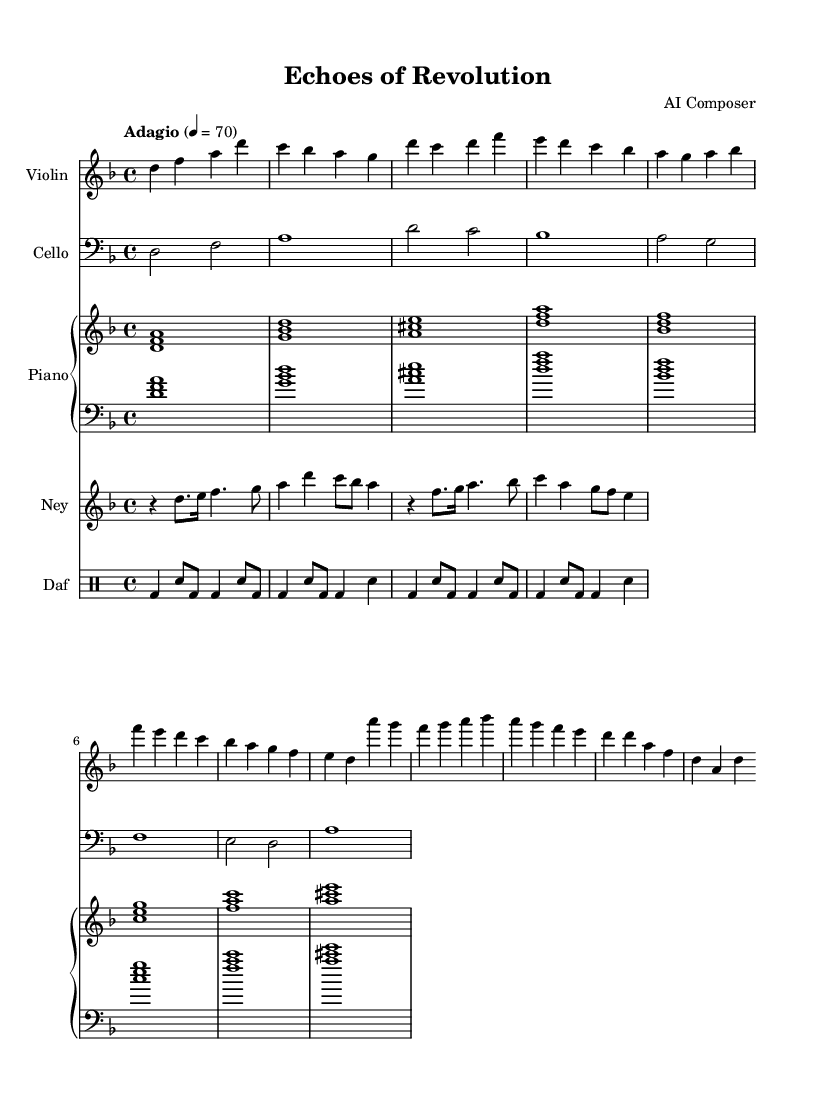What is the key signature of this music? The music is in D minor, which has one flat (B♭). The key signature can be found at the beginning of the staff, where the flat symbol is indicated.
Answer: D minor What is the time signature of this piece? The time signature is 4/4, which indicates that there are four beats in each measure and the quarter note gets one beat. This can be seen at the beginning of the score, right after the key signature.
Answer: 4/4 What is the tempo marking for this music? The tempo marking shown is "Adagio," which generally means a slow tempo. The beats per minute indicated is 70, providing a specific speed for the performance. This information is displayed at the beginning of the score alongside the tempo indication.
Answer: Adagio How many measures are in the violin part? Counting the measures in the violin part from the provided music, there are a total of 5 measures. This can be calculated by counting the vertical lines (bar lines) that signify the end of each measure within the staff.
Answer: 5 Which instruments are featured in this score? The score includes five instruments: Violin, Cello, Piano, Ney, and Daf. Each instrument is indicated with its name at the start of its corresponding staff throughout the score.
Answer: Violin, Cello, Piano, Ney, Daf What is the main theme's rhythm pattern in the daf part? The rhythm pattern in the daf part consists of a combination of bass drum (bd) and snare (sn) notes. The specific pattern repeats in sections throughout the score, showing a consistent rhythmic structure characteristic of percussion music. To identify this, one can look at the drumming notation and count the rhythmic symbols presented in a measure.
Answer: bd, sn 